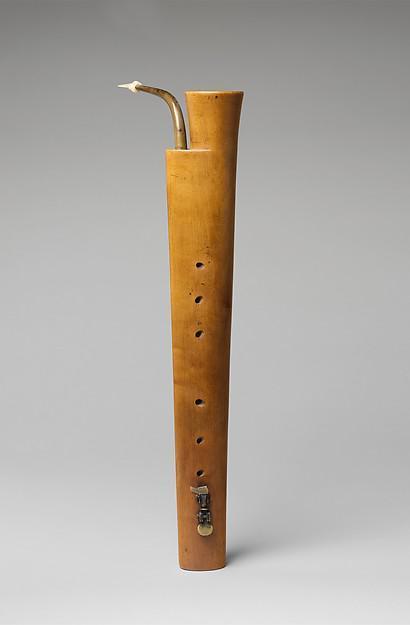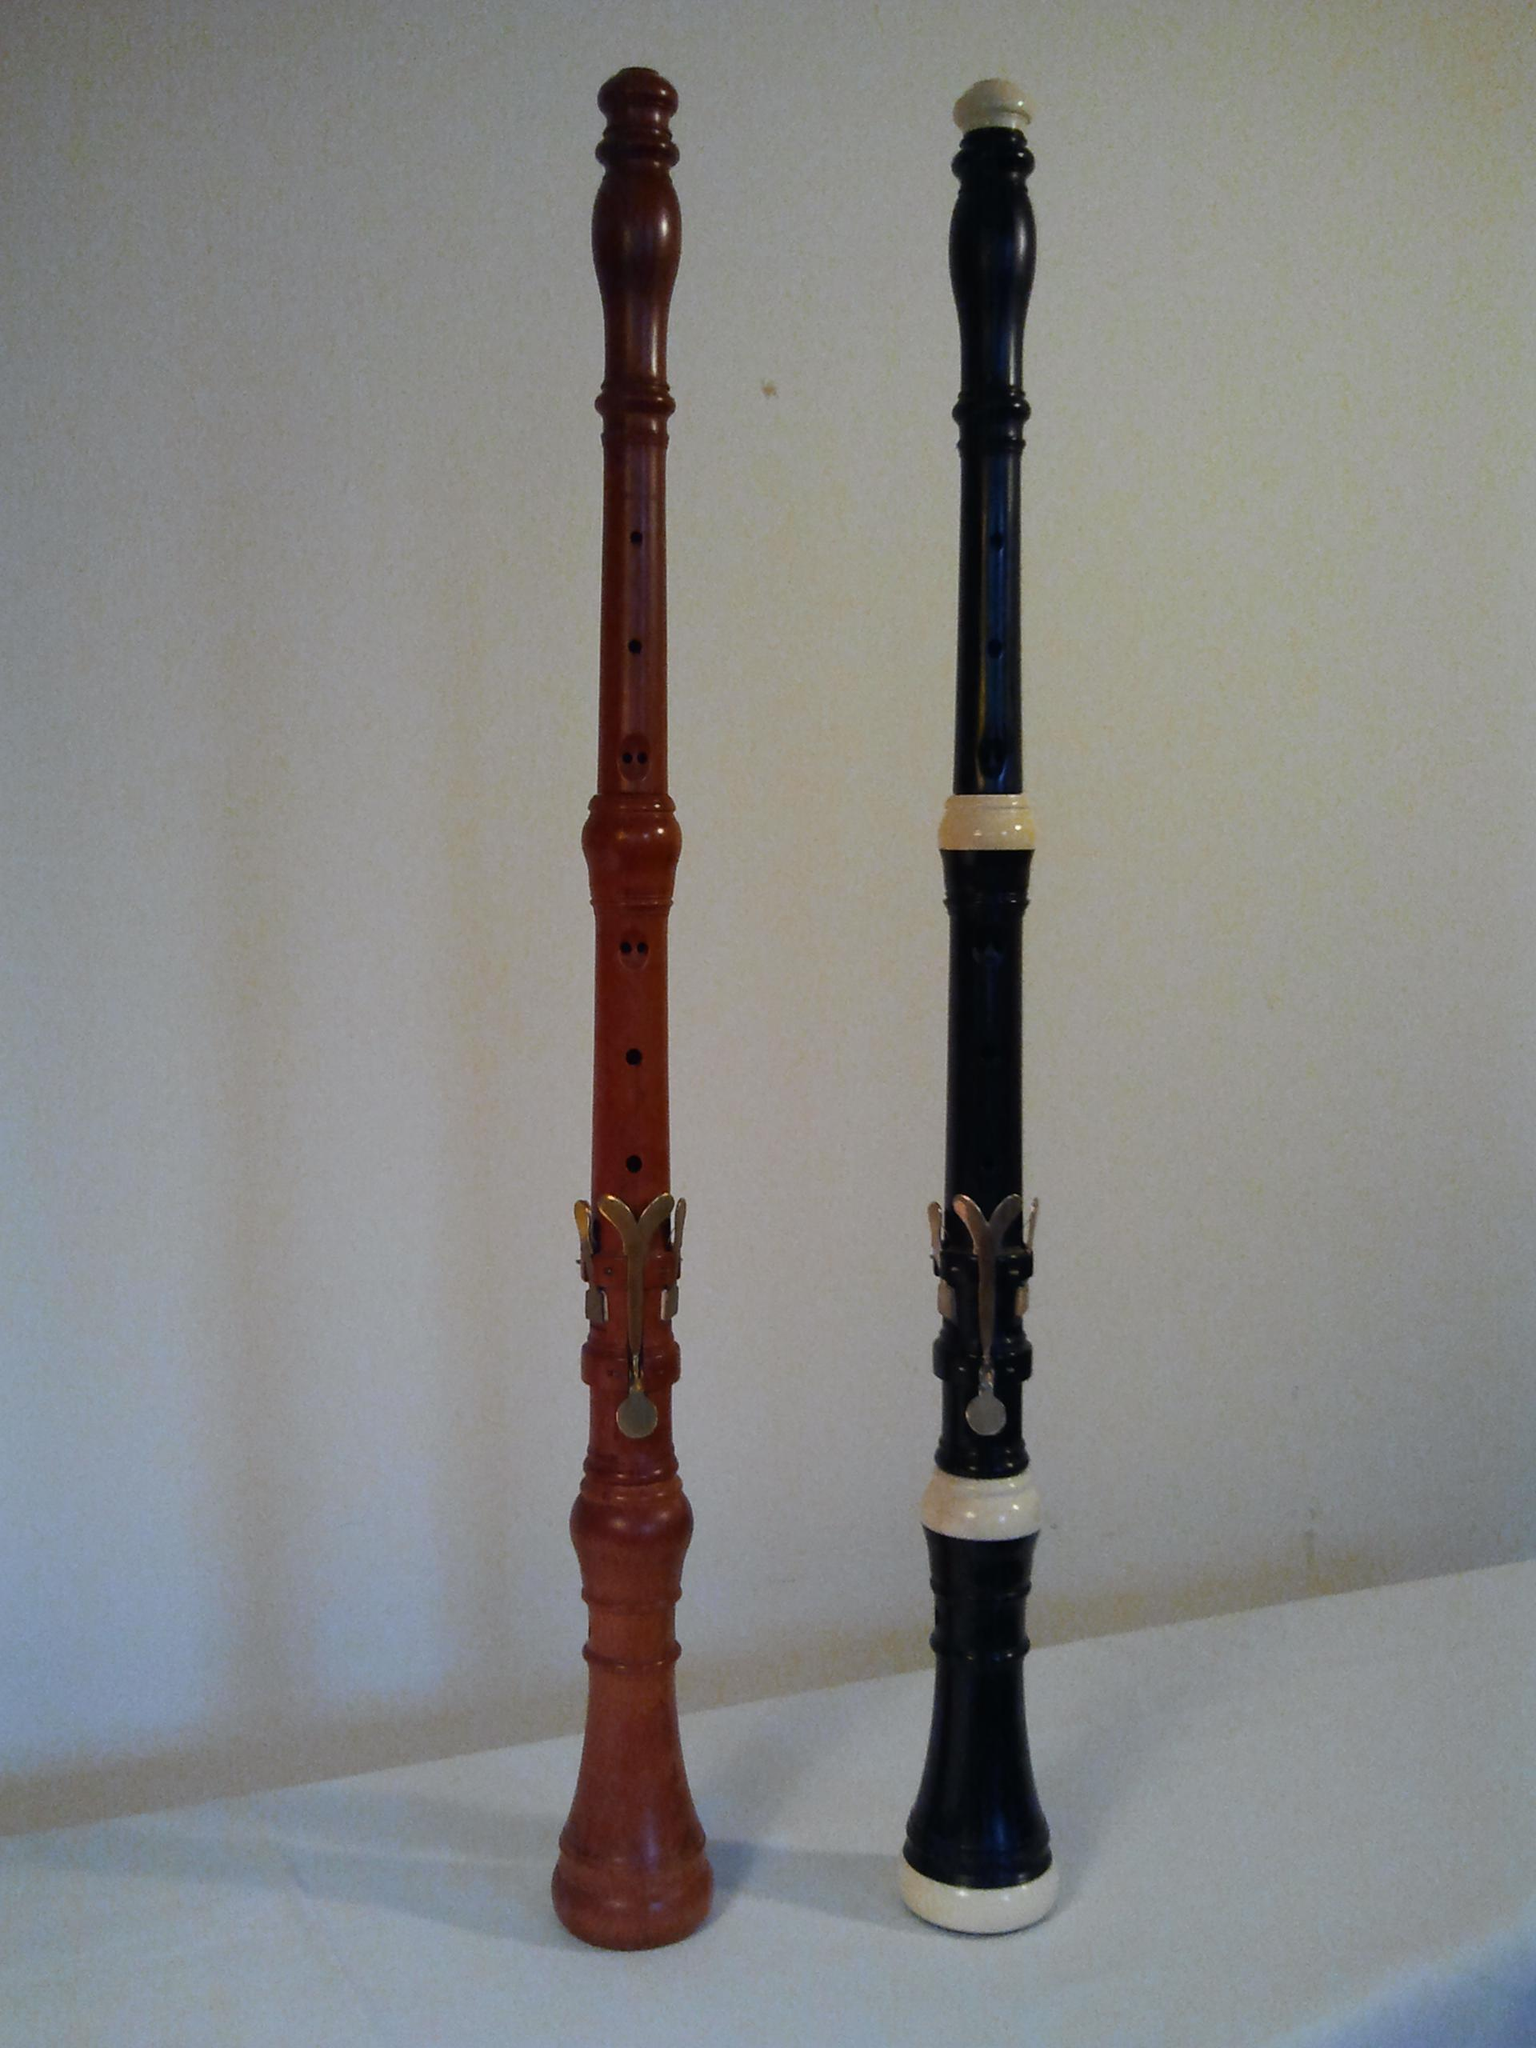The first image is the image on the left, the second image is the image on the right. Examine the images to the left and right. Is the description "One image contains exactly three wind instruments and the other contains exactly five." accurate? Answer yes or no. No. The first image is the image on the left, the second image is the image on the right. Examine the images to the left and right. Is the description "There are three clarinets in the right image." accurate? Answer yes or no. No. 